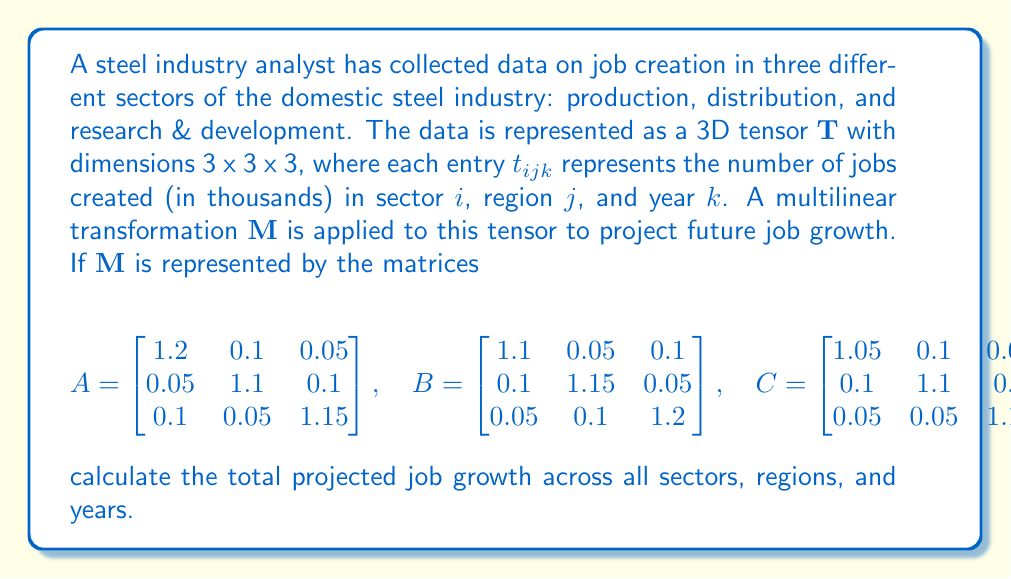Can you answer this question? To solve this problem, we need to follow these steps:

1) The multilinear transformation $\mathbf{M}$ applied to tensor $\mathbf{T}$ can be represented as:

   $$\mathbf{M}(\mathbf{T}) = \mathbf{T} \times_1 A \times_2 B \times_3 C$$

   where $\times_n$ denotes the n-mode product.

2) The result of this transformation will be another 3 x 3 x 3 tensor. To calculate the total projected job growth, we need to sum all elements of this resulting tensor.

3) However, we don't need to explicitly calculate each element of the resulting tensor. We can use the linearity property of tensor operations and the fact that the sum of all elements in a tensor is equal to the inner product of the tensor with an all-ones tensor of the same shape.

4) Let $\mathbf{J}$ be the 3 x 3 x 3 all-ones tensor. Then the total projected job growth is:

   $$\langle \mathbf{M}(\mathbf{T}), \mathbf{J} \rangle = \langle \mathbf{T} \times_1 A \times_2 B \times_3 C, \mathbf{J} \rangle$$

5) Using the properties of tensor operations, this is equivalent to:

   $$\langle \mathbf{T}, \mathbf{J} \times_1 A^T \times_2 B^T \times_3 C^T \rangle$$

6) The product $\mathbf{J} \times_1 A^T \times_2 B^T \times_3 C^T$ is a 3 x 3 x 3 tensor where each element is the sum of all elements in $A$, $B$, and $C$.

7) The sum of all elements in each of $A$, $B$, and $C$ is 3.55.

8) Therefore, each element of $\mathbf{J} \times_1 A^T \times_2 B^T \times_3 C^T$ is $3.55^3 = 44.70875$.

9) The inner product of $\mathbf{T}$ with this tensor is equivalent to multiplying the sum of all elements in $\mathbf{T}$ by 44.70875.

10) If we denote the sum of all elements in $\mathbf{T}$ as $S$, then the total projected job growth is $44.70875S$ thousand jobs.
Answer: $44.70875S$ thousand jobs, where $S$ is the sum of all elements in the original tensor $\mathbf{T}$. 